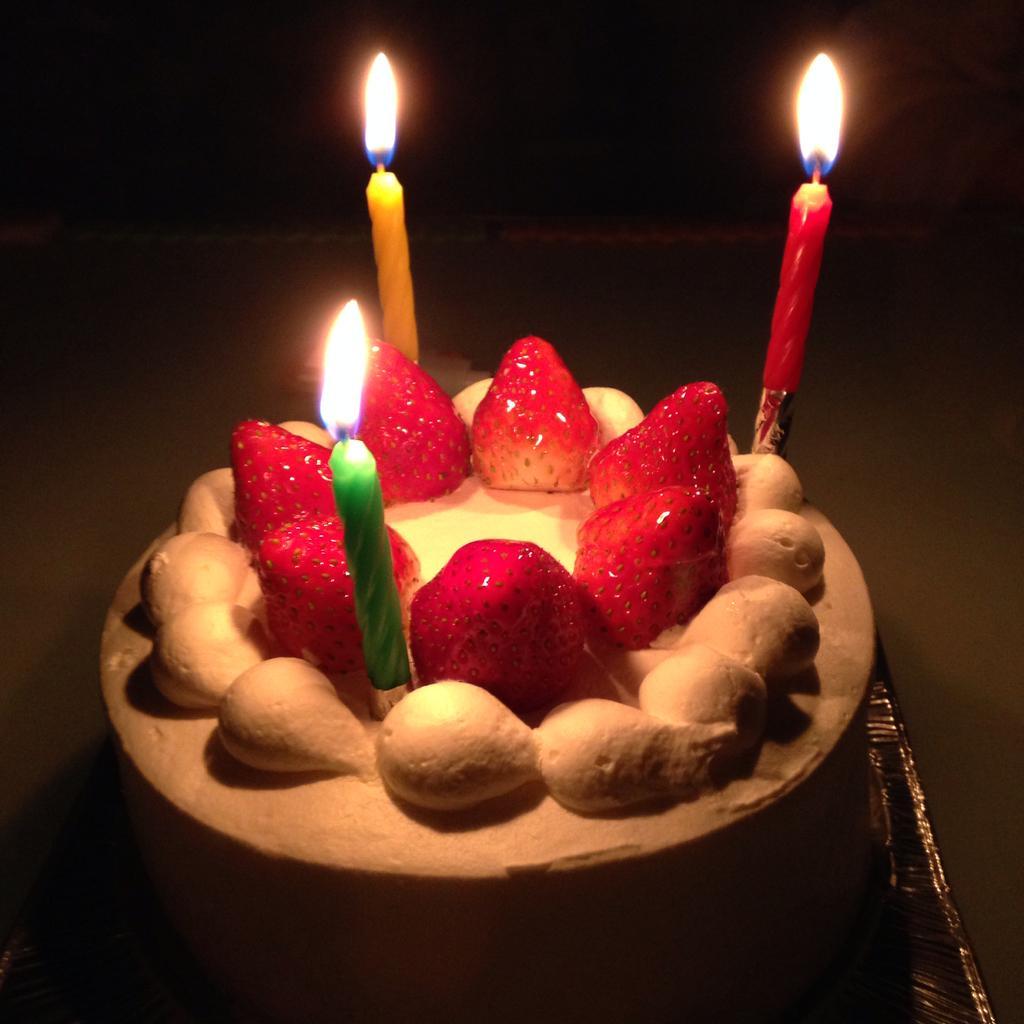In one or two sentences, can you explain what this image depicts? In this picture I can see a cake in front, on which there are strawberries and 3 candles. I see that it is dark in the background. 